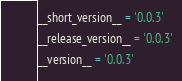Convert code to text. <code><loc_0><loc_0><loc_500><loc_500><_Python_>__short_version__ = '0.0.3'
__release_version__ = '0.0.3'
__version__ = '0.0.3'
</code> 